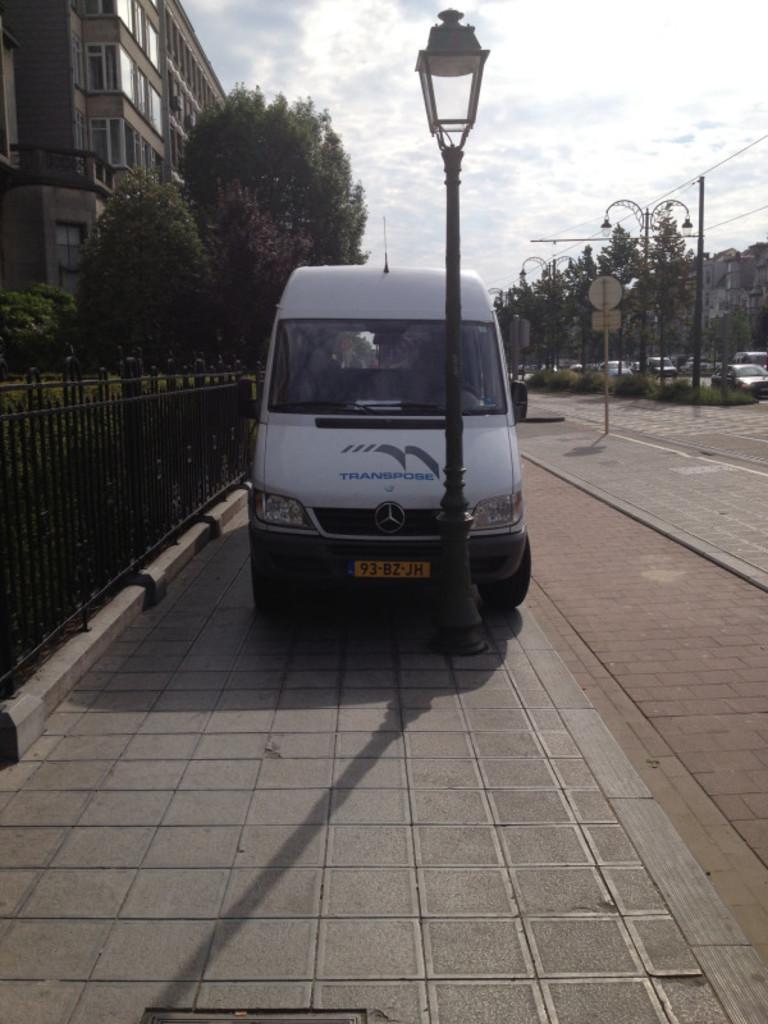What is the plate number?
Your response must be concise. 93-bz-jh. 